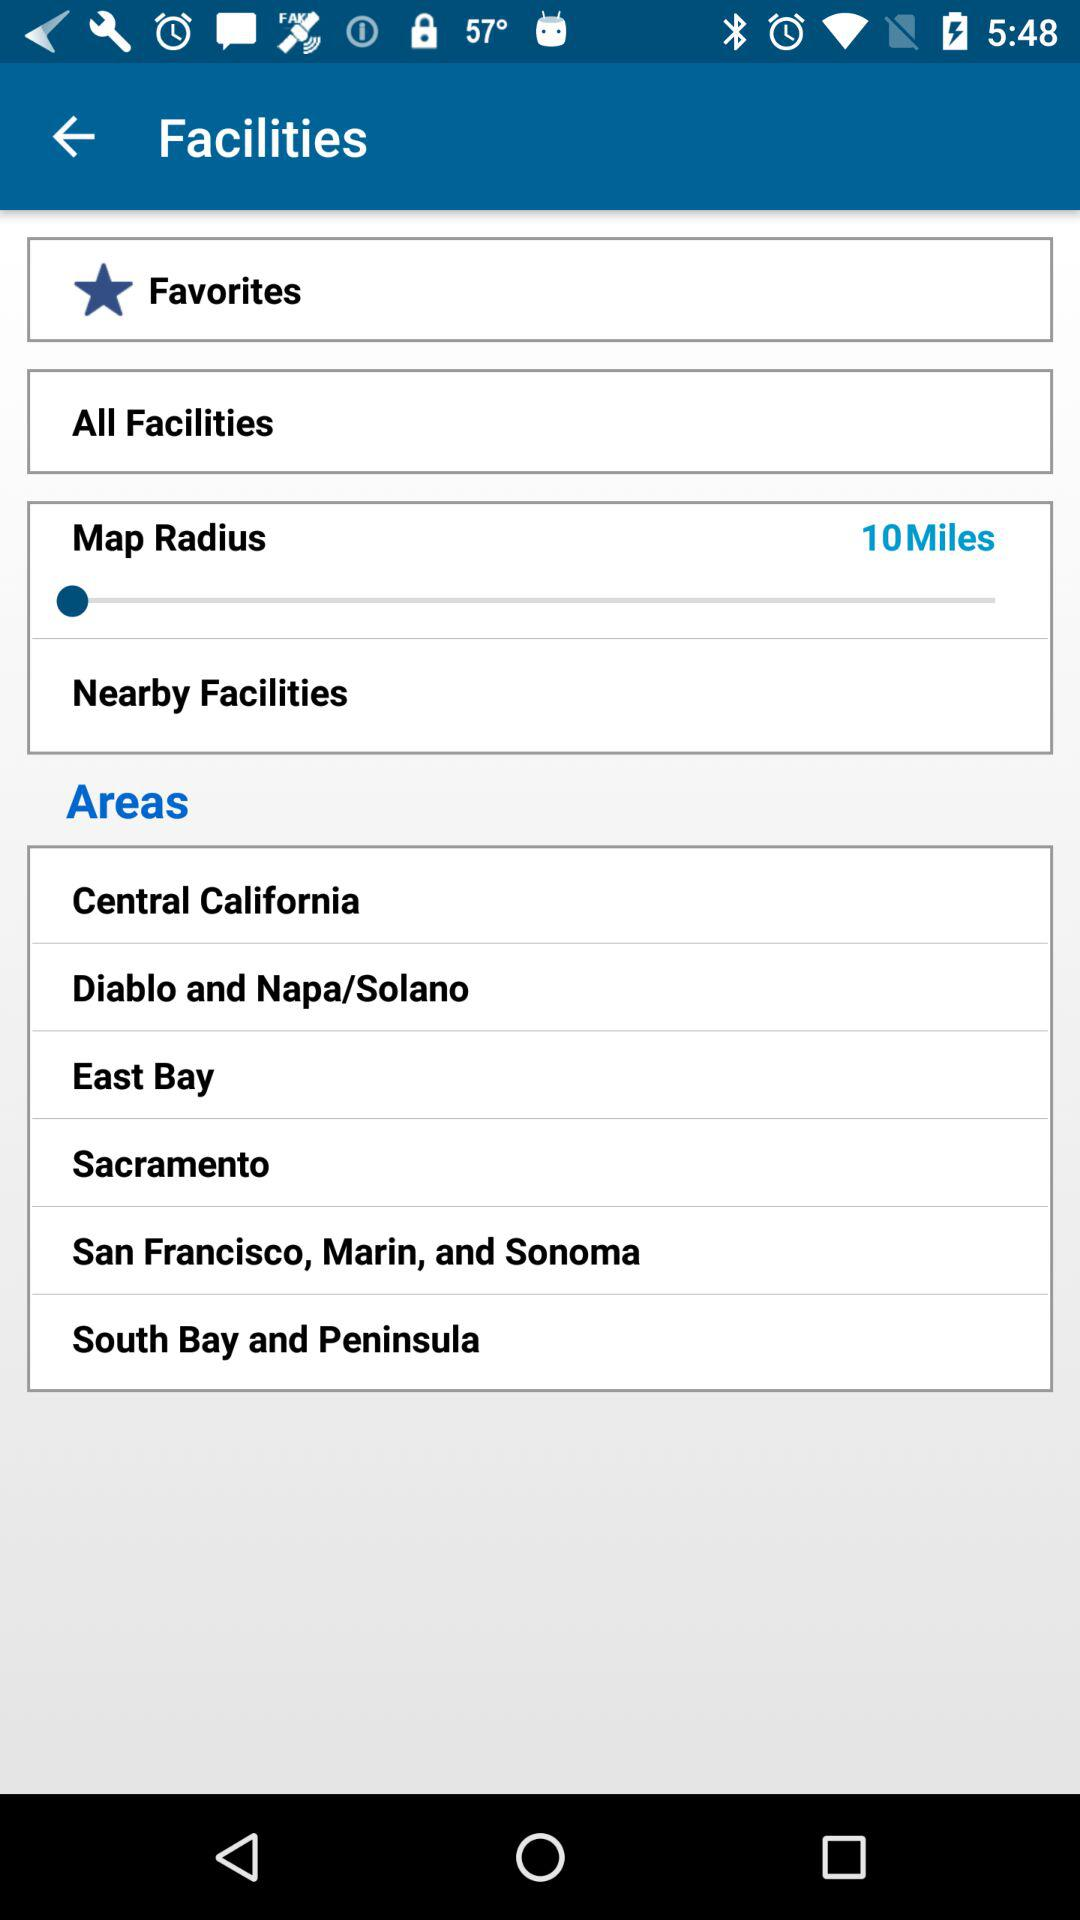Which are the different areas? The different areas are Central California; Diablo and Napa/Solano; East Bay; Sacramento; San Francisco, Marin and Sonoma; South Bay and Peninsula. 